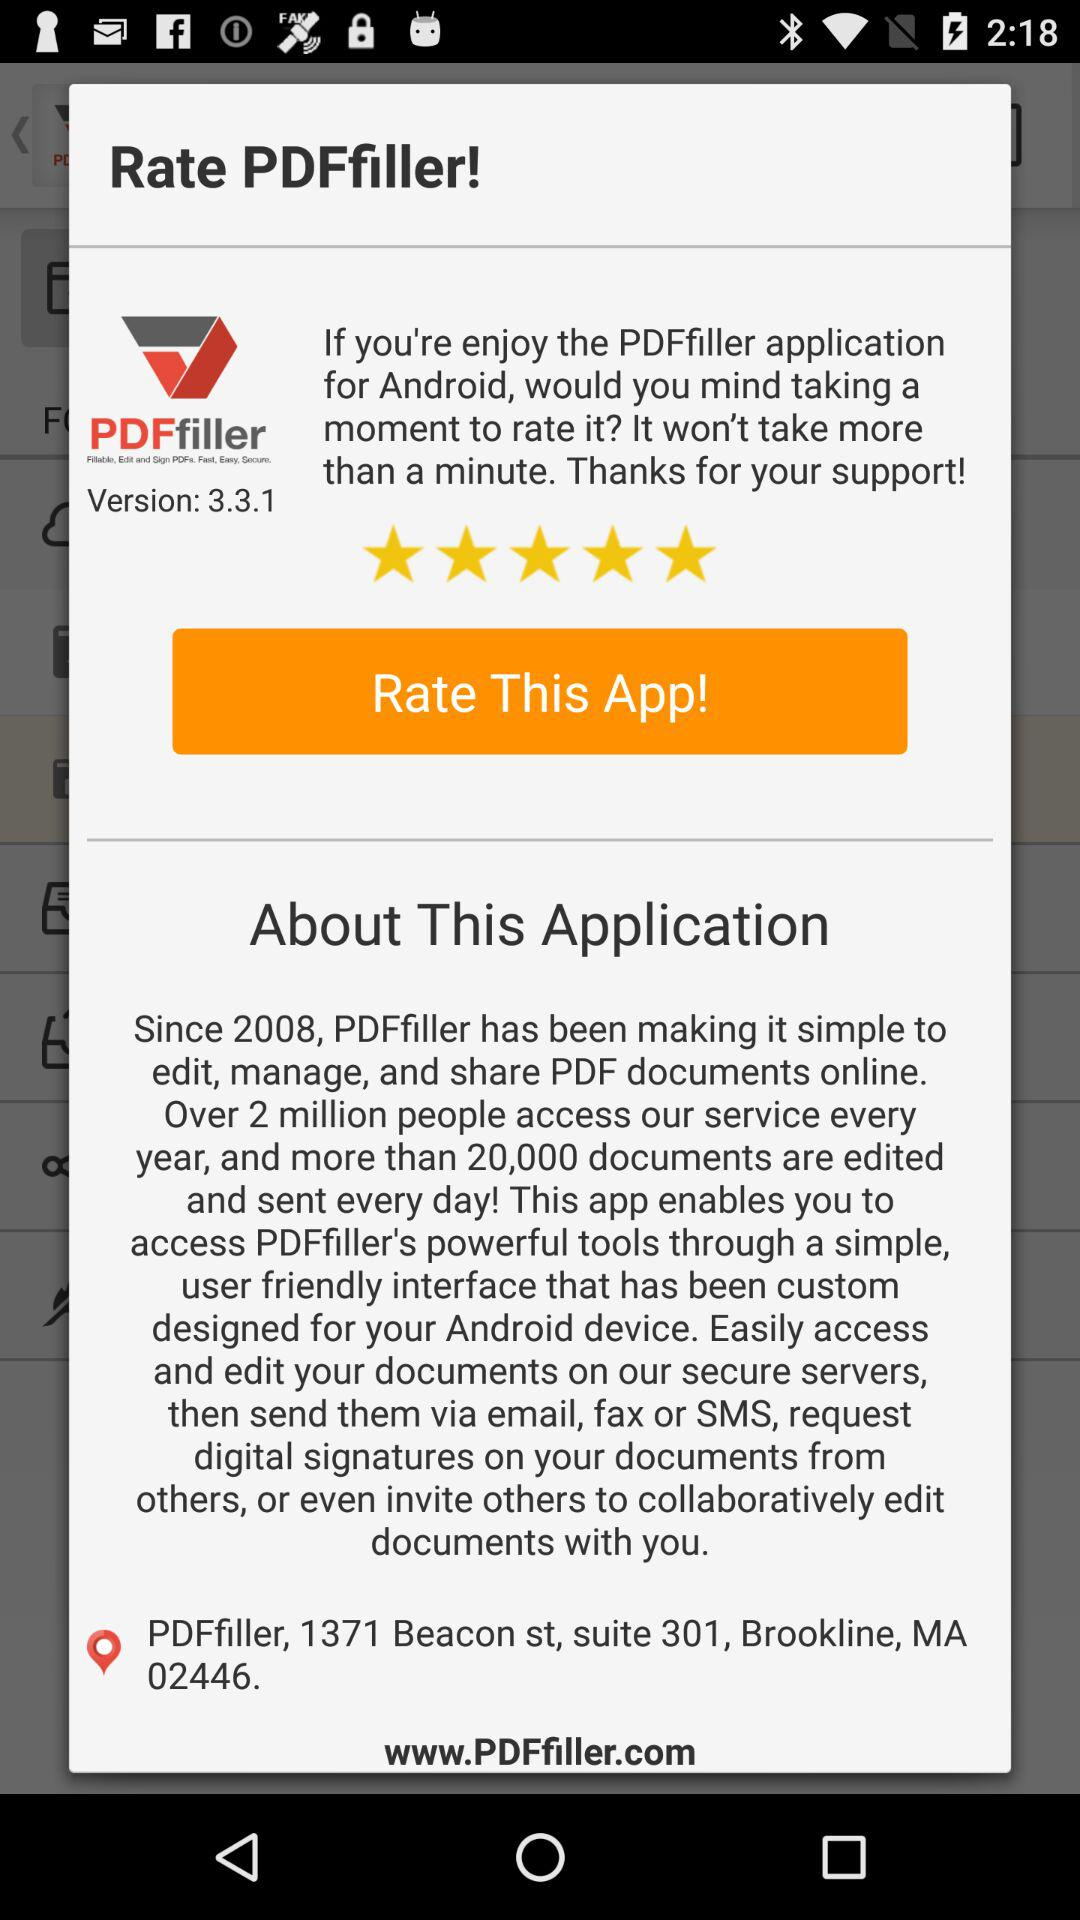What is the version? The version is 3.3.1. 